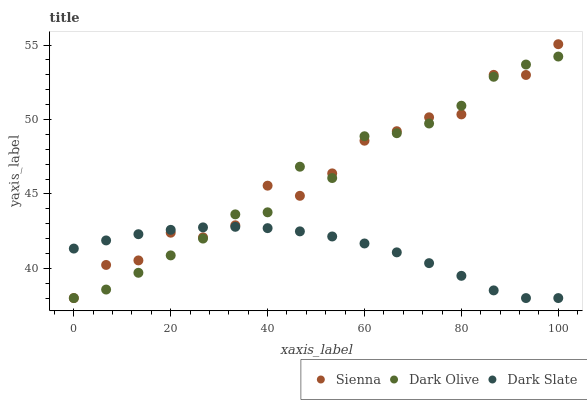Does Dark Slate have the minimum area under the curve?
Answer yes or no. Yes. Does Sienna have the maximum area under the curve?
Answer yes or no. Yes. Does Dark Olive have the minimum area under the curve?
Answer yes or no. No. Does Dark Olive have the maximum area under the curve?
Answer yes or no. No. Is Dark Slate the smoothest?
Answer yes or no. Yes. Is Sienna the roughest?
Answer yes or no. Yes. Is Dark Olive the smoothest?
Answer yes or no. No. Is Dark Olive the roughest?
Answer yes or no. No. Does Sienna have the lowest value?
Answer yes or no. Yes. Does Sienna have the highest value?
Answer yes or no. Yes. Does Dark Olive have the highest value?
Answer yes or no. No. Does Sienna intersect Dark Slate?
Answer yes or no. Yes. Is Sienna less than Dark Slate?
Answer yes or no. No. Is Sienna greater than Dark Slate?
Answer yes or no. No. 